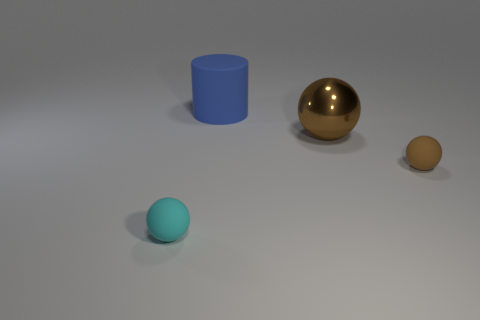Subtract all gray cubes. How many brown spheres are left? 2 Subtract all big balls. How many balls are left? 2 Add 1 big blue rubber things. How many objects exist? 5 Subtract all cyan spheres. How many spheres are left? 2 Subtract all cylinders. How many objects are left? 3 Subtract 0 yellow balls. How many objects are left? 4 Subtract all yellow balls. Subtract all blue cylinders. How many balls are left? 3 Subtract all blue rubber objects. Subtract all brown rubber things. How many objects are left? 2 Add 2 small matte spheres. How many small matte spheres are left? 4 Add 2 tiny blue balls. How many tiny blue balls exist? 2 